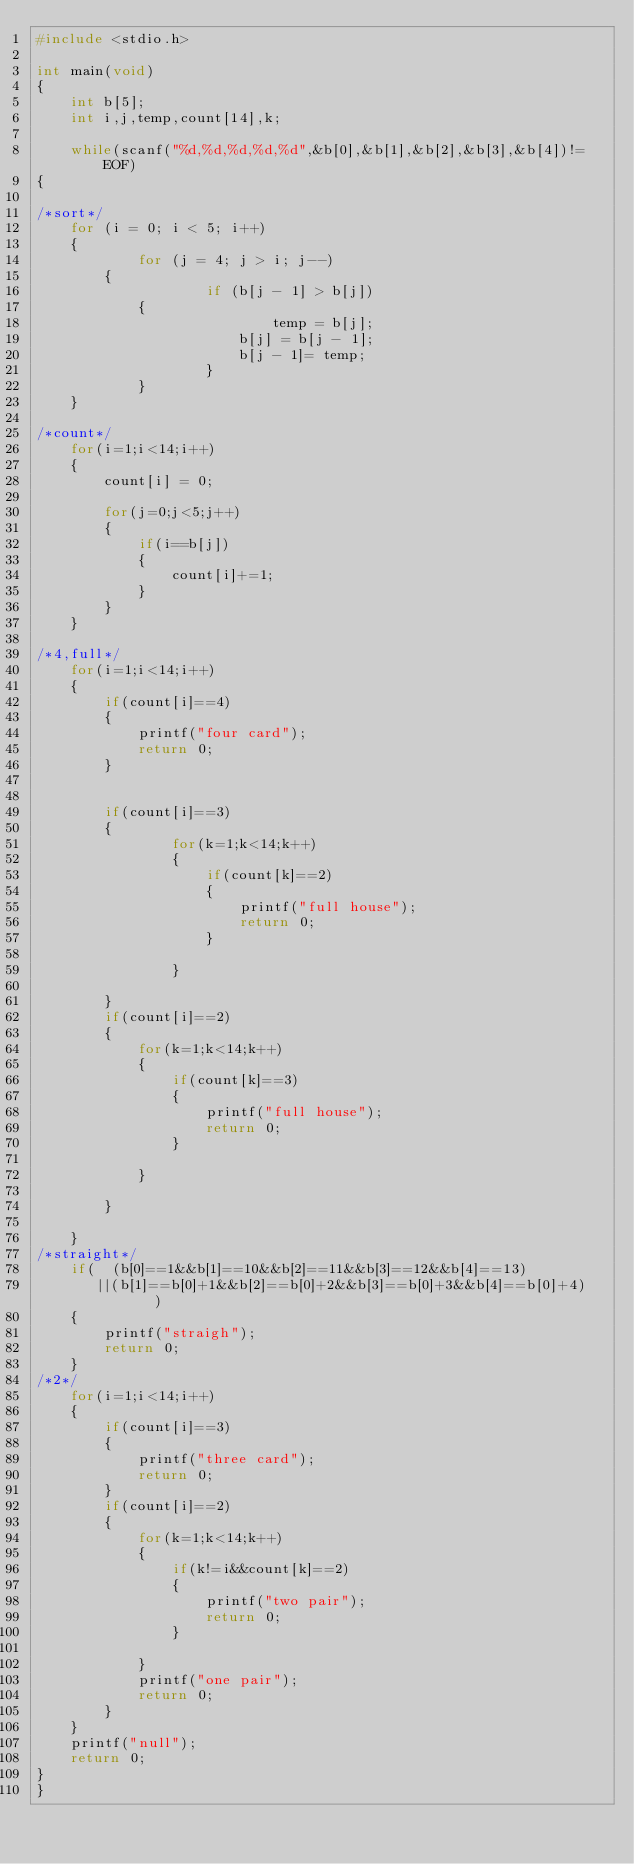<code> <loc_0><loc_0><loc_500><loc_500><_C_>#include <stdio.h>

int main(void)
{
	int b[5];
	int i,j,temp,count[14],k;

	while(scanf("%d,%d,%d,%d,%d",&b[0],&b[1],&b[2],&b[3],&b[4])!= EOF)
{

/*sort*/
	for (i = 0; i < 5; i++) 
	{
        	for (j = 4; j > i; j--) 
		{
            		if (b[j - 1] > b[j])
			{ 
            	    		temp = b[j];
                		b[j] = b[j - 1];
                		b[j - 1]= temp;
            		}
        	}	
	}

/*count*/
	for(i=1;i<14;i++)
	{	
		count[i] = 0;

		for(j=0;j<5;j++)
		{
			if(i==b[j])
			{
				count[i]+=1;
			}
		}
	}

/*4,full*/
	for(i=1;i<14;i++)
	{			
		if(count[i]==4)
		{
			printf("four card");
			return 0;
		}
	

		if(count[i]==3)
		{
				for(k=1;k<14;k++)
				{
					if(count[k]==2)
					{
						printf("full house");
						return 0;
					}

				}

		}
		if(count[i]==2)
		{
			for(k=1;k<14;k++)
			{
				if(count[k]==3)
				{
					printf("full house");
					return 0;
				}

			}

		}

	}
/*straight*/
	if(  (b[0]==1&&b[1]==10&&b[2]==11&&b[3]==12&&b[4]==13)
	   ||(b[1]==b[0]+1&&b[2]==b[0]+2&&b[3]==b[0]+3&&b[4]==b[0]+4)	)
	{
		printf("straigh");
		return 0;
	}
/*2*/	
	for(i=1;i<14;i++)
	{	
		if(count[i]==3)
		{
			printf("three card");
			return 0;
		}
		if(count[i]==2)
		{
			for(k=1;k<14;k++)
			{
				if(k!=i&&count[k]==2)
				{
					printf("two pair");
					return 0;
				}

			}
			printf("one pair");
			return 0;
		}
	}
	printf("null");
	return 0;
}
}</code> 